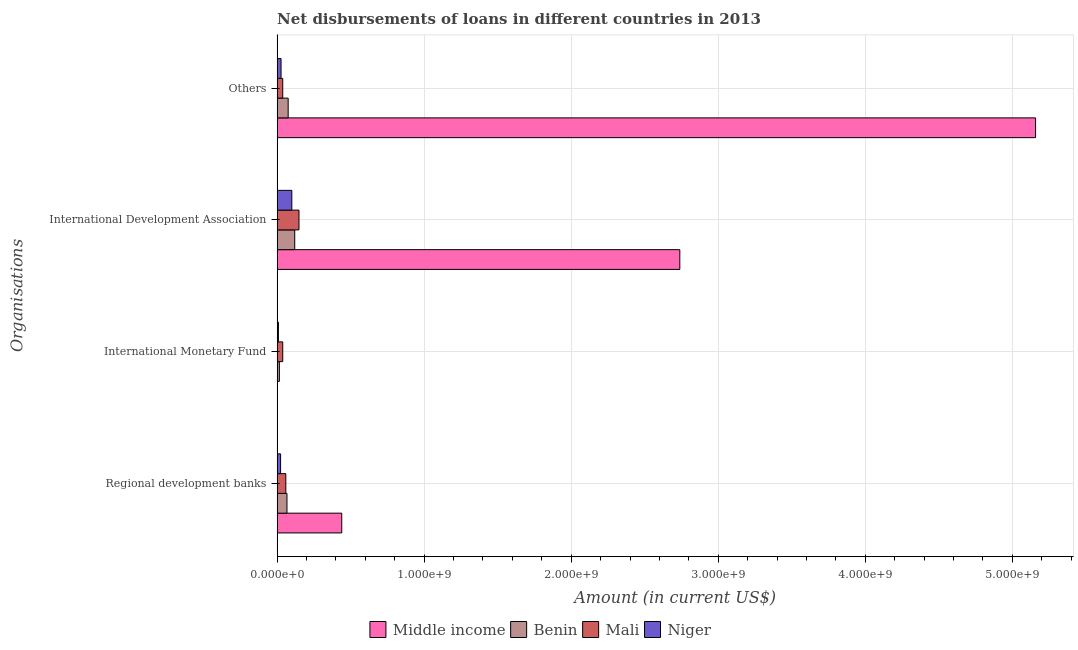How many groups of bars are there?
Offer a terse response. 4. Are the number of bars on each tick of the Y-axis equal?
Give a very brief answer. Yes. How many bars are there on the 2nd tick from the top?
Offer a terse response. 4. What is the label of the 2nd group of bars from the top?
Give a very brief answer. International Development Association. What is the amount of loan disimbursed by other organisations in Benin?
Your response must be concise. 7.51e+07. Across all countries, what is the maximum amount of loan disimbursed by international monetary fund?
Offer a very short reply. 3.83e+07. Across all countries, what is the minimum amount of loan disimbursed by international monetary fund?
Ensure brevity in your answer.  2.15e+06. In which country was the amount of loan disimbursed by regional development banks minimum?
Provide a short and direct response. Niger. What is the total amount of loan disimbursed by regional development banks in the graph?
Ensure brevity in your answer.  5.89e+08. What is the difference between the amount of loan disimbursed by international development association in Benin and that in Niger?
Keep it short and to the point. 1.98e+07. What is the difference between the amount of loan disimbursed by other organisations in Mali and the amount of loan disimbursed by international monetary fund in Niger?
Offer a very short reply. 2.93e+07. What is the average amount of loan disimbursed by regional development banks per country?
Make the answer very short. 1.47e+08. What is the difference between the amount of loan disimbursed by regional development banks and amount of loan disimbursed by international monetary fund in Benin?
Provide a succinct answer. 5.17e+07. What is the ratio of the amount of loan disimbursed by other organisations in Benin to that in Niger?
Provide a succinct answer. 2.81. Is the amount of loan disimbursed by other organisations in Middle income less than that in Niger?
Your answer should be very brief. No. What is the difference between the highest and the second highest amount of loan disimbursed by regional development banks?
Keep it short and to the point. 3.73e+08. What is the difference between the highest and the lowest amount of loan disimbursed by international monetary fund?
Give a very brief answer. 3.61e+07. In how many countries, is the amount of loan disimbursed by international development association greater than the average amount of loan disimbursed by international development association taken over all countries?
Provide a succinct answer. 1. Is it the case that in every country, the sum of the amount of loan disimbursed by international development association and amount of loan disimbursed by regional development banks is greater than the sum of amount of loan disimbursed by international monetary fund and amount of loan disimbursed by other organisations?
Offer a terse response. No. What does the 3rd bar from the top in Others represents?
Provide a short and direct response. Benin. What does the 4th bar from the bottom in International Monetary Fund represents?
Make the answer very short. Niger. Is it the case that in every country, the sum of the amount of loan disimbursed by regional development banks and amount of loan disimbursed by international monetary fund is greater than the amount of loan disimbursed by international development association?
Offer a very short reply. No. How many bars are there?
Your answer should be very brief. 16. What is the difference between two consecutive major ticks on the X-axis?
Your answer should be very brief. 1.00e+09. Are the values on the major ticks of X-axis written in scientific E-notation?
Your answer should be compact. Yes. How many legend labels are there?
Your answer should be very brief. 4. How are the legend labels stacked?
Ensure brevity in your answer.  Horizontal. What is the title of the graph?
Keep it short and to the point. Net disbursements of loans in different countries in 2013. What is the label or title of the X-axis?
Your response must be concise. Amount (in current US$). What is the label or title of the Y-axis?
Offer a terse response. Organisations. What is the Amount (in current US$) of Middle income in Regional development banks?
Make the answer very short. 4.39e+08. What is the Amount (in current US$) in Benin in Regional development banks?
Provide a succinct answer. 6.69e+07. What is the Amount (in current US$) in Mali in Regional development banks?
Your response must be concise. 5.91e+07. What is the Amount (in current US$) in Niger in Regional development banks?
Offer a terse response. 2.36e+07. What is the Amount (in current US$) in Middle income in International Monetary Fund?
Your response must be concise. 2.15e+06. What is the Amount (in current US$) in Benin in International Monetary Fund?
Give a very brief answer. 1.52e+07. What is the Amount (in current US$) in Mali in International Monetary Fund?
Give a very brief answer. 3.83e+07. What is the Amount (in current US$) of Niger in International Monetary Fund?
Provide a short and direct response. 8.82e+06. What is the Amount (in current US$) of Middle income in International Development Association?
Keep it short and to the point. 2.74e+09. What is the Amount (in current US$) in Benin in International Development Association?
Offer a very short reply. 1.20e+08. What is the Amount (in current US$) of Mali in International Development Association?
Provide a short and direct response. 1.49e+08. What is the Amount (in current US$) in Niger in International Development Association?
Offer a very short reply. 9.99e+07. What is the Amount (in current US$) in Middle income in Others?
Your answer should be compact. 5.16e+09. What is the Amount (in current US$) in Benin in Others?
Make the answer very short. 7.51e+07. What is the Amount (in current US$) in Mali in Others?
Your response must be concise. 3.81e+07. What is the Amount (in current US$) of Niger in Others?
Your response must be concise. 2.67e+07. Across all Organisations, what is the maximum Amount (in current US$) in Middle income?
Make the answer very short. 5.16e+09. Across all Organisations, what is the maximum Amount (in current US$) in Benin?
Provide a succinct answer. 1.20e+08. Across all Organisations, what is the maximum Amount (in current US$) of Mali?
Your answer should be compact. 1.49e+08. Across all Organisations, what is the maximum Amount (in current US$) of Niger?
Give a very brief answer. 9.99e+07. Across all Organisations, what is the minimum Amount (in current US$) of Middle income?
Provide a short and direct response. 2.15e+06. Across all Organisations, what is the minimum Amount (in current US$) in Benin?
Your answer should be compact. 1.52e+07. Across all Organisations, what is the minimum Amount (in current US$) in Mali?
Your answer should be very brief. 3.81e+07. Across all Organisations, what is the minimum Amount (in current US$) in Niger?
Offer a very short reply. 8.82e+06. What is the total Amount (in current US$) in Middle income in the graph?
Ensure brevity in your answer.  8.34e+09. What is the total Amount (in current US$) of Benin in the graph?
Keep it short and to the point. 2.77e+08. What is the total Amount (in current US$) in Mali in the graph?
Give a very brief answer. 2.84e+08. What is the total Amount (in current US$) in Niger in the graph?
Offer a very short reply. 1.59e+08. What is the difference between the Amount (in current US$) in Middle income in Regional development banks and that in International Monetary Fund?
Keep it short and to the point. 4.37e+08. What is the difference between the Amount (in current US$) in Benin in Regional development banks and that in International Monetary Fund?
Your answer should be very brief. 5.17e+07. What is the difference between the Amount (in current US$) of Mali in Regional development banks and that in International Monetary Fund?
Offer a terse response. 2.08e+07. What is the difference between the Amount (in current US$) in Niger in Regional development banks and that in International Monetary Fund?
Your response must be concise. 1.48e+07. What is the difference between the Amount (in current US$) in Middle income in Regional development banks and that in International Development Association?
Your response must be concise. -2.30e+09. What is the difference between the Amount (in current US$) of Benin in Regional development banks and that in International Development Association?
Your answer should be compact. -5.28e+07. What is the difference between the Amount (in current US$) in Mali in Regional development banks and that in International Development Association?
Your answer should be compact. -8.96e+07. What is the difference between the Amount (in current US$) of Niger in Regional development banks and that in International Development Association?
Provide a succinct answer. -7.63e+07. What is the difference between the Amount (in current US$) of Middle income in Regional development banks and that in Others?
Provide a short and direct response. -4.72e+09. What is the difference between the Amount (in current US$) in Benin in Regional development banks and that in Others?
Your answer should be compact. -8.15e+06. What is the difference between the Amount (in current US$) in Mali in Regional development banks and that in Others?
Offer a very short reply. 2.10e+07. What is the difference between the Amount (in current US$) in Niger in Regional development banks and that in Others?
Offer a terse response. -3.09e+06. What is the difference between the Amount (in current US$) of Middle income in International Monetary Fund and that in International Development Association?
Ensure brevity in your answer.  -2.74e+09. What is the difference between the Amount (in current US$) in Benin in International Monetary Fund and that in International Development Association?
Your answer should be very brief. -1.05e+08. What is the difference between the Amount (in current US$) in Mali in International Monetary Fund and that in International Development Association?
Ensure brevity in your answer.  -1.10e+08. What is the difference between the Amount (in current US$) of Niger in International Monetary Fund and that in International Development Association?
Give a very brief answer. -9.11e+07. What is the difference between the Amount (in current US$) of Middle income in International Monetary Fund and that in Others?
Make the answer very short. -5.16e+09. What is the difference between the Amount (in current US$) of Benin in International Monetary Fund and that in Others?
Offer a terse response. -5.98e+07. What is the difference between the Amount (in current US$) in Niger in International Monetary Fund and that in Others?
Provide a succinct answer. -1.79e+07. What is the difference between the Amount (in current US$) of Middle income in International Development Association and that in Others?
Keep it short and to the point. -2.42e+09. What is the difference between the Amount (in current US$) of Benin in International Development Association and that in Others?
Offer a terse response. 4.47e+07. What is the difference between the Amount (in current US$) of Mali in International Development Association and that in Others?
Provide a short and direct response. 1.11e+08. What is the difference between the Amount (in current US$) in Niger in International Development Association and that in Others?
Keep it short and to the point. 7.32e+07. What is the difference between the Amount (in current US$) in Middle income in Regional development banks and the Amount (in current US$) in Benin in International Monetary Fund?
Your response must be concise. 4.24e+08. What is the difference between the Amount (in current US$) of Middle income in Regional development banks and the Amount (in current US$) of Mali in International Monetary Fund?
Provide a succinct answer. 4.01e+08. What is the difference between the Amount (in current US$) in Middle income in Regional development banks and the Amount (in current US$) in Niger in International Monetary Fund?
Your answer should be very brief. 4.31e+08. What is the difference between the Amount (in current US$) in Benin in Regional development banks and the Amount (in current US$) in Mali in International Monetary Fund?
Your response must be concise. 2.87e+07. What is the difference between the Amount (in current US$) in Benin in Regional development banks and the Amount (in current US$) in Niger in International Monetary Fund?
Offer a very short reply. 5.81e+07. What is the difference between the Amount (in current US$) in Mali in Regional development banks and the Amount (in current US$) in Niger in International Monetary Fund?
Ensure brevity in your answer.  5.02e+07. What is the difference between the Amount (in current US$) in Middle income in Regional development banks and the Amount (in current US$) in Benin in International Development Association?
Your response must be concise. 3.20e+08. What is the difference between the Amount (in current US$) in Middle income in Regional development banks and the Amount (in current US$) in Mali in International Development Association?
Keep it short and to the point. 2.91e+08. What is the difference between the Amount (in current US$) of Middle income in Regional development banks and the Amount (in current US$) of Niger in International Development Association?
Make the answer very short. 3.40e+08. What is the difference between the Amount (in current US$) in Benin in Regional development banks and the Amount (in current US$) in Mali in International Development Association?
Your response must be concise. -8.17e+07. What is the difference between the Amount (in current US$) of Benin in Regional development banks and the Amount (in current US$) of Niger in International Development Association?
Make the answer very short. -3.30e+07. What is the difference between the Amount (in current US$) of Mali in Regional development banks and the Amount (in current US$) of Niger in International Development Association?
Offer a very short reply. -4.09e+07. What is the difference between the Amount (in current US$) in Middle income in Regional development banks and the Amount (in current US$) in Benin in Others?
Give a very brief answer. 3.64e+08. What is the difference between the Amount (in current US$) of Middle income in Regional development banks and the Amount (in current US$) of Mali in Others?
Ensure brevity in your answer.  4.01e+08. What is the difference between the Amount (in current US$) in Middle income in Regional development banks and the Amount (in current US$) in Niger in Others?
Offer a terse response. 4.13e+08. What is the difference between the Amount (in current US$) of Benin in Regional development banks and the Amount (in current US$) of Mali in Others?
Provide a short and direct response. 2.88e+07. What is the difference between the Amount (in current US$) in Benin in Regional development banks and the Amount (in current US$) in Niger in Others?
Ensure brevity in your answer.  4.03e+07. What is the difference between the Amount (in current US$) of Mali in Regional development banks and the Amount (in current US$) of Niger in Others?
Your answer should be very brief. 3.24e+07. What is the difference between the Amount (in current US$) of Middle income in International Monetary Fund and the Amount (in current US$) of Benin in International Development Association?
Your response must be concise. -1.18e+08. What is the difference between the Amount (in current US$) in Middle income in International Monetary Fund and the Amount (in current US$) in Mali in International Development Association?
Your answer should be very brief. -1.46e+08. What is the difference between the Amount (in current US$) of Middle income in International Monetary Fund and the Amount (in current US$) of Niger in International Development Association?
Offer a very short reply. -9.78e+07. What is the difference between the Amount (in current US$) of Benin in International Monetary Fund and the Amount (in current US$) of Mali in International Development Association?
Your answer should be very brief. -1.33e+08. What is the difference between the Amount (in current US$) in Benin in International Monetary Fund and the Amount (in current US$) in Niger in International Development Association?
Your response must be concise. -8.47e+07. What is the difference between the Amount (in current US$) of Mali in International Monetary Fund and the Amount (in current US$) of Niger in International Development Association?
Provide a succinct answer. -6.16e+07. What is the difference between the Amount (in current US$) in Middle income in International Monetary Fund and the Amount (in current US$) in Benin in Others?
Provide a succinct answer. -7.29e+07. What is the difference between the Amount (in current US$) of Middle income in International Monetary Fund and the Amount (in current US$) of Mali in Others?
Provide a short and direct response. -3.60e+07. What is the difference between the Amount (in current US$) in Middle income in International Monetary Fund and the Amount (in current US$) in Niger in Others?
Make the answer very short. -2.45e+07. What is the difference between the Amount (in current US$) of Benin in International Monetary Fund and the Amount (in current US$) of Mali in Others?
Your answer should be very brief. -2.29e+07. What is the difference between the Amount (in current US$) of Benin in International Monetary Fund and the Amount (in current US$) of Niger in Others?
Your response must be concise. -1.14e+07. What is the difference between the Amount (in current US$) of Mali in International Monetary Fund and the Amount (in current US$) of Niger in Others?
Ensure brevity in your answer.  1.16e+07. What is the difference between the Amount (in current US$) of Middle income in International Development Association and the Amount (in current US$) of Benin in Others?
Provide a succinct answer. 2.66e+09. What is the difference between the Amount (in current US$) in Middle income in International Development Association and the Amount (in current US$) in Mali in Others?
Ensure brevity in your answer.  2.70e+09. What is the difference between the Amount (in current US$) of Middle income in International Development Association and the Amount (in current US$) of Niger in Others?
Your answer should be compact. 2.71e+09. What is the difference between the Amount (in current US$) of Benin in International Development Association and the Amount (in current US$) of Mali in Others?
Offer a very short reply. 8.17e+07. What is the difference between the Amount (in current US$) of Benin in International Development Association and the Amount (in current US$) of Niger in Others?
Make the answer very short. 9.31e+07. What is the difference between the Amount (in current US$) in Mali in International Development Association and the Amount (in current US$) in Niger in Others?
Offer a terse response. 1.22e+08. What is the average Amount (in current US$) in Middle income per Organisations?
Offer a very short reply. 2.08e+09. What is the average Amount (in current US$) of Benin per Organisations?
Your response must be concise. 6.93e+07. What is the average Amount (in current US$) in Mali per Organisations?
Your answer should be very brief. 7.10e+07. What is the average Amount (in current US$) in Niger per Organisations?
Provide a succinct answer. 3.98e+07. What is the difference between the Amount (in current US$) in Middle income and Amount (in current US$) in Benin in Regional development banks?
Provide a short and direct response. 3.73e+08. What is the difference between the Amount (in current US$) of Middle income and Amount (in current US$) of Mali in Regional development banks?
Your answer should be very brief. 3.80e+08. What is the difference between the Amount (in current US$) in Middle income and Amount (in current US$) in Niger in Regional development banks?
Provide a succinct answer. 4.16e+08. What is the difference between the Amount (in current US$) of Benin and Amount (in current US$) of Mali in Regional development banks?
Ensure brevity in your answer.  7.89e+06. What is the difference between the Amount (in current US$) of Benin and Amount (in current US$) of Niger in Regional development banks?
Provide a short and direct response. 4.33e+07. What is the difference between the Amount (in current US$) of Mali and Amount (in current US$) of Niger in Regional development banks?
Your answer should be compact. 3.55e+07. What is the difference between the Amount (in current US$) of Middle income and Amount (in current US$) of Benin in International Monetary Fund?
Ensure brevity in your answer.  -1.31e+07. What is the difference between the Amount (in current US$) of Middle income and Amount (in current US$) of Mali in International Monetary Fund?
Your answer should be very brief. -3.61e+07. What is the difference between the Amount (in current US$) in Middle income and Amount (in current US$) in Niger in International Monetary Fund?
Keep it short and to the point. -6.67e+06. What is the difference between the Amount (in current US$) of Benin and Amount (in current US$) of Mali in International Monetary Fund?
Give a very brief answer. -2.30e+07. What is the difference between the Amount (in current US$) in Benin and Amount (in current US$) in Niger in International Monetary Fund?
Make the answer very short. 6.43e+06. What is the difference between the Amount (in current US$) in Mali and Amount (in current US$) in Niger in International Monetary Fund?
Offer a very short reply. 2.95e+07. What is the difference between the Amount (in current US$) in Middle income and Amount (in current US$) in Benin in International Development Association?
Your answer should be very brief. 2.62e+09. What is the difference between the Amount (in current US$) of Middle income and Amount (in current US$) of Mali in International Development Association?
Keep it short and to the point. 2.59e+09. What is the difference between the Amount (in current US$) in Middle income and Amount (in current US$) in Niger in International Development Association?
Offer a terse response. 2.64e+09. What is the difference between the Amount (in current US$) of Benin and Amount (in current US$) of Mali in International Development Association?
Make the answer very short. -2.89e+07. What is the difference between the Amount (in current US$) in Benin and Amount (in current US$) in Niger in International Development Association?
Your answer should be compact. 1.98e+07. What is the difference between the Amount (in current US$) in Mali and Amount (in current US$) in Niger in International Development Association?
Your answer should be very brief. 4.87e+07. What is the difference between the Amount (in current US$) in Middle income and Amount (in current US$) in Benin in Others?
Ensure brevity in your answer.  5.08e+09. What is the difference between the Amount (in current US$) of Middle income and Amount (in current US$) of Mali in Others?
Ensure brevity in your answer.  5.12e+09. What is the difference between the Amount (in current US$) in Middle income and Amount (in current US$) in Niger in Others?
Give a very brief answer. 5.13e+09. What is the difference between the Amount (in current US$) of Benin and Amount (in current US$) of Mali in Others?
Provide a short and direct response. 3.70e+07. What is the difference between the Amount (in current US$) in Benin and Amount (in current US$) in Niger in Others?
Provide a succinct answer. 4.84e+07. What is the difference between the Amount (in current US$) of Mali and Amount (in current US$) of Niger in Others?
Your answer should be very brief. 1.14e+07. What is the ratio of the Amount (in current US$) of Middle income in Regional development banks to that in International Monetary Fund?
Keep it short and to the point. 204.38. What is the ratio of the Amount (in current US$) in Benin in Regional development banks to that in International Monetary Fund?
Your response must be concise. 4.39. What is the ratio of the Amount (in current US$) of Mali in Regional development banks to that in International Monetary Fund?
Make the answer very short. 1.54. What is the ratio of the Amount (in current US$) in Niger in Regional development banks to that in International Monetary Fund?
Keep it short and to the point. 2.68. What is the ratio of the Amount (in current US$) in Middle income in Regional development banks to that in International Development Association?
Ensure brevity in your answer.  0.16. What is the ratio of the Amount (in current US$) in Benin in Regional development banks to that in International Development Association?
Give a very brief answer. 0.56. What is the ratio of the Amount (in current US$) of Mali in Regional development banks to that in International Development Association?
Your response must be concise. 0.4. What is the ratio of the Amount (in current US$) of Niger in Regional development banks to that in International Development Association?
Keep it short and to the point. 0.24. What is the ratio of the Amount (in current US$) of Middle income in Regional development banks to that in Others?
Your response must be concise. 0.09. What is the ratio of the Amount (in current US$) in Benin in Regional development banks to that in Others?
Offer a terse response. 0.89. What is the ratio of the Amount (in current US$) in Mali in Regional development banks to that in Others?
Give a very brief answer. 1.55. What is the ratio of the Amount (in current US$) of Niger in Regional development banks to that in Others?
Provide a succinct answer. 0.88. What is the ratio of the Amount (in current US$) of Middle income in International Monetary Fund to that in International Development Association?
Your answer should be compact. 0. What is the ratio of the Amount (in current US$) in Benin in International Monetary Fund to that in International Development Association?
Make the answer very short. 0.13. What is the ratio of the Amount (in current US$) in Mali in International Monetary Fund to that in International Development Association?
Offer a very short reply. 0.26. What is the ratio of the Amount (in current US$) in Niger in International Monetary Fund to that in International Development Association?
Ensure brevity in your answer.  0.09. What is the ratio of the Amount (in current US$) in Middle income in International Monetary Fund to that in Others?
Offer a very short reply. 0. What is the ratio of the Amount (in current US$) of Benin in International Monetary Fund to that in Others?
Your answer should be compact. 0.2. What is the ratio of the Amount (in current US$) of Mali in International Monetary Fund to that in Others?
Ensure brevity in your answer.  1. What is the ratio of the Amount (in current US$) in Niger in International Monetary Fund to that in Others?
Offer a very short reply. 0.33. What is the ratio of the Amount (in current US$) in Middle income in International Development Association to that in Others?
Provide a succinct answer. 0.53. What is the ratio of the Amount (in current US$) in Benin in International Development Association to that in Others?
Give a very brief answer. 1.59. What is the ratio of the Amount (in current US$) of Mali in International Development Association to that in Others?
Your answer should be compact. 3.9. What is the ratio of the Amount (in current US$) of Niger in International Development Association to that in Others?
Provide a succinct answer. 3.75. What is the difference between the highest and the second highest Amount (in current US$) of Middle income?
Give a very brief answer. 2.42e+09. What is the difference between the highest and the second highest Amount (in current US$) in Benin?
Ensure brevity in your answer.  4.47e+07. What is the difference between the highest and the second highest Amount (in current US$) in Mali?
Offer a terse response. 8.96e+07. What is the difference between the highest and the second highest Amount (in current US$) of Niger?
Your answer should be compact. 7.32e+07. What is the difference between the highest and the lowest Amount (in current US$) in Middle income?
Give a very brief answer. 5.16e+09. What is the difference between the highest and the lowest Amount (in current US$) of Benin?
Make the answer very short. 1.05e+08. What is the difference between the highest and the lowest Amount (in current US$) of Mali?
Keep it short and to the point. 1.11e+08. What is the difference between the highest and the lowest Amount (in current US$) of Niger?
Make the answer very short. 9.11e+07. 